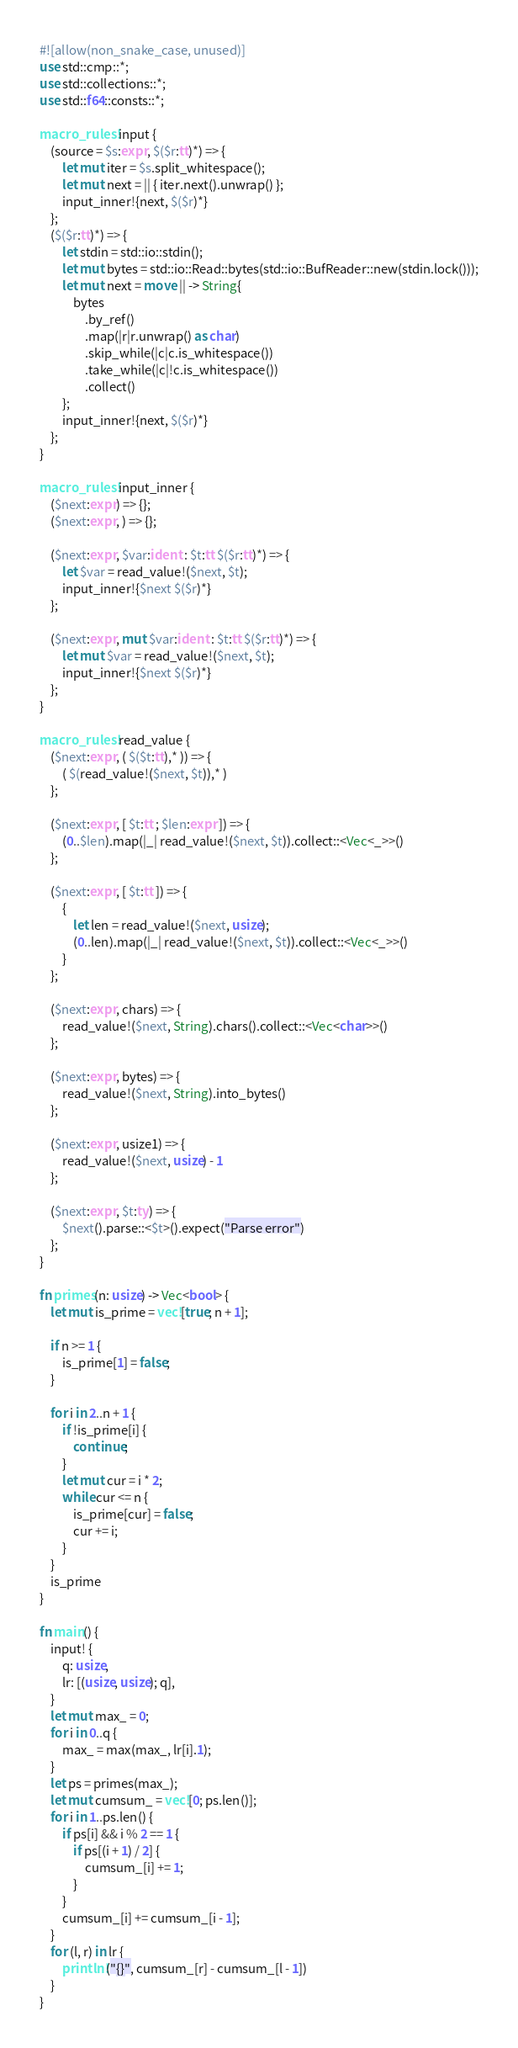<code> <loc_0><loc_0><loc_500><loc_500><_Rust_>#![allow(non_snake_case, unused)]
use std::cmp::*;
use std::collections::*;
use std::f64::consts::*;

macro_rules! input {
    (source = $s:expr, $($r:tt)*) => {
        let mut iter = $s.split_whitespace();
        let mut next = || { iter.next().unwrap() };
        input_inner!{next, $($r)*}
    };
    ($($r:tt)*) => {
        let stdin = std::io::stdin();
        let mut bytes = std::io::Read::bytes(std::io::BufReader::new(stdin.lock()));
        let mut next = move || -> String{
            bytes
                .by_ref()
                .map(|r|r.unwrap() as char)
                .skip_while(|c|c.is_whitespace())
                .take_while(|c|!c.is_whitespace())
                .collect()
        };
        input_inner!{next, $($r)*}
    };
}

macro_rules! input_inner {
    ($next:expr) => {};
    ($next:expr, ) => {};

    ($next:expr, $var:ident : $t:tt $($r:tt)*) => {
        let $var = read_value!($next, $t);
        input_inner!{$next $($r)*}
    };

    ($next:expr, mut $var:ident : $t:tt $($r:tt)*) => {
        let mut $var = read_value!($next, $t);
        input_inner!{$next $($r)*}
    };
}

macro_rules! read_value {
    ($next:expr, ( $($t:tt),* )) => {
        ( $(read_value!($next, $t)),* )
    };

    ($next:expr, [ $t:tt ; $len:expr ]) => {
        (0..$len).map(|_| read_value!($next, $t)).collect::<Vec<_>>()
    };

    ($next:expr, [ $t:tt ]) => {
        {
            let len = read_value!($next, usize);
            (0..len).map(|_| read_value!($next, $t)).collect::<Vec<_>>()
        }
    };

    ($next:expr, chars) => {
        read_value!($next, String).chars().collect::<Vec<char>>()
    };

    ($next:expr, bytes) => {
        read_value!($next, String).into_bytes()
    };

    ($next:expr, usize1) => {
        read_value!($next, usize) - 1
    };

    ($next:expr, $t:ty) => {
        $next().parse::<$t>().expect("Parse error")
    };
}

fn primes(n: usize) -> Vec<bool> {
    let mut is_prime = vec![true; n + 1];

    if n >= 1 {
        is_prime[1] = false;
    }

    for i in 2..n + 1 {
        if !is_prime[i] {
            continue;
        }
        let mut cur = i * 2;
        while cur <= n {
            is_prime[cur] = false;
            cur += i;
        }
    }
    is_prime
}

fn main() {
    input! {
        q: usize,
        lr: [(usize, usize); q],
    }
    let mut max_ = 0;
    for i in 0..q {
        max_ = max(max_, lr[i].1);
    }
    let ps = primes(max_);
    let mut cumsum_ = vec![0; ps.len()];
    for i in 1..ps.len() {
        if ps[i] && i % 2 == 1 {
            if ps[(i + 1) / 2] {
                cumsum_[i] += 1;
            }
        }
        cumsum_[i] += cumsum_[i - 1];
    }
    for (l, r) in lr {
        println!("{}", cumsum_[r] - cumsum_[l - 1])
    }
}
</code> 